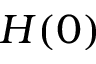Convert formula to latex. <formula><loc_0><loc_0><loc_500><loc_500>H ( 0 )</formula> 